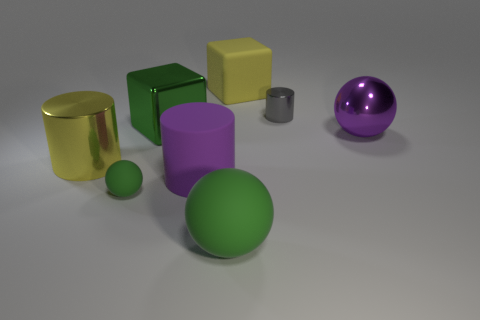Subtract all shiny cylinders. How many cylinders are left? 1 Add 1 green shiny objects. How many objects exist? 9 Subtract all green blocks. How many green balls are left? 2 Subtract all spheres. How many objects are left? 5 Subtract all purple cylinders. How many cylinders are left? 2 Subtract all blue blocks. Subtract all brown spheres. How many blocks are left? 2 Subtract all big purple metal balls. Subtract all large purple rubber objects. How many objects are left? 6 Add 5 matte things. How many matte things are left? 9 Add 8 blue objects. How many blue objects exist? 8 Subtract 0 brown blocks. How many objects are left? 8 